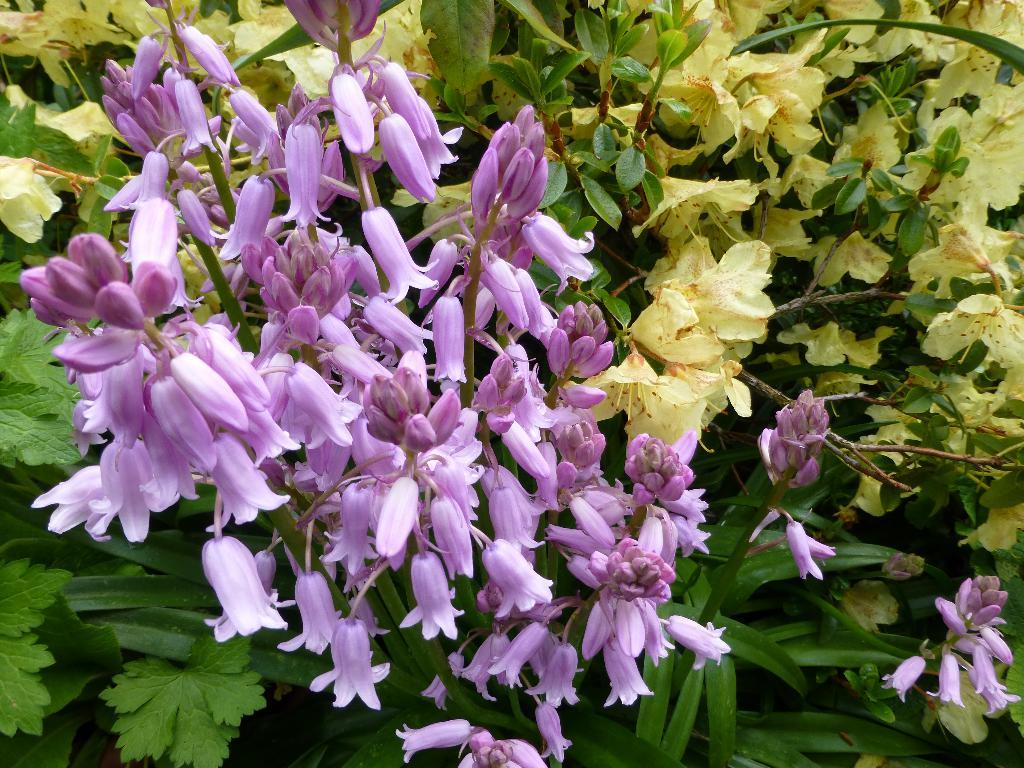What colors of flowers can be seen in the image? There are purple and yellow color flowers in the image. What else is present in the image besides flowers? There are leaves in the image. What type of drug can be seen growing on the farm in the image? There is no farm or drug present in the image; it features flowers and leaves. How many apples are visible on the tree in the image? There is no tree or apples present in the image. 